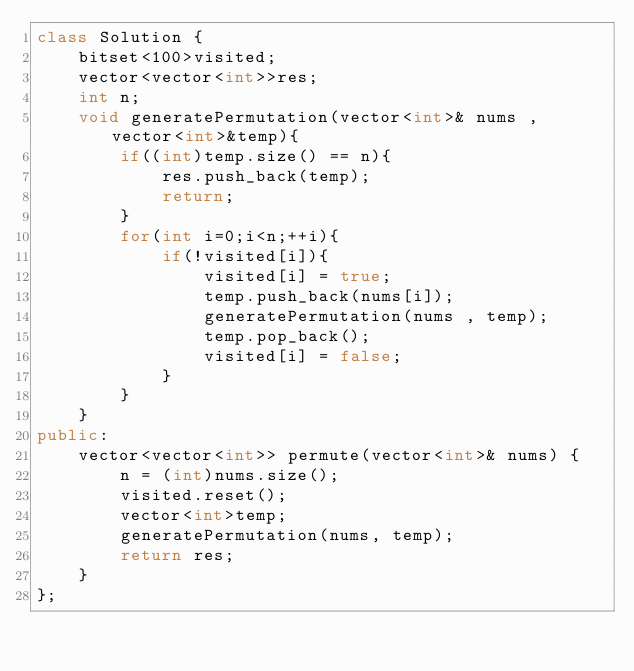Convert code to text. <code><loc_0><loc_0><loc_500><loc_500><_C++_>class Solution {
    bitset<100>visited;
    vector<vector<int>>res;
    int n; 
    void generatePermutation(vector<int>& nums , vector<int>&temp){
        if((int)temp.size() == n){
            res.push_back(temp);
            return;
        }
        for(int i=0;i<n;++i){
            if(!visited[i]){
                visited[i] = true;
                temp.push_back(nums[i]);
                generatePermutation(nums , temp);
                temp.pop_back();
                visited[i] = false;
            }
        }
    }
public:
    vector<vector<int>> permute(vector<int>& nums) {
        n = (int)nums.size();
        visited.reset();
        vector<int>temp;
        generatePermutation(nums, temp);
        return res;
    }
};

</code> 